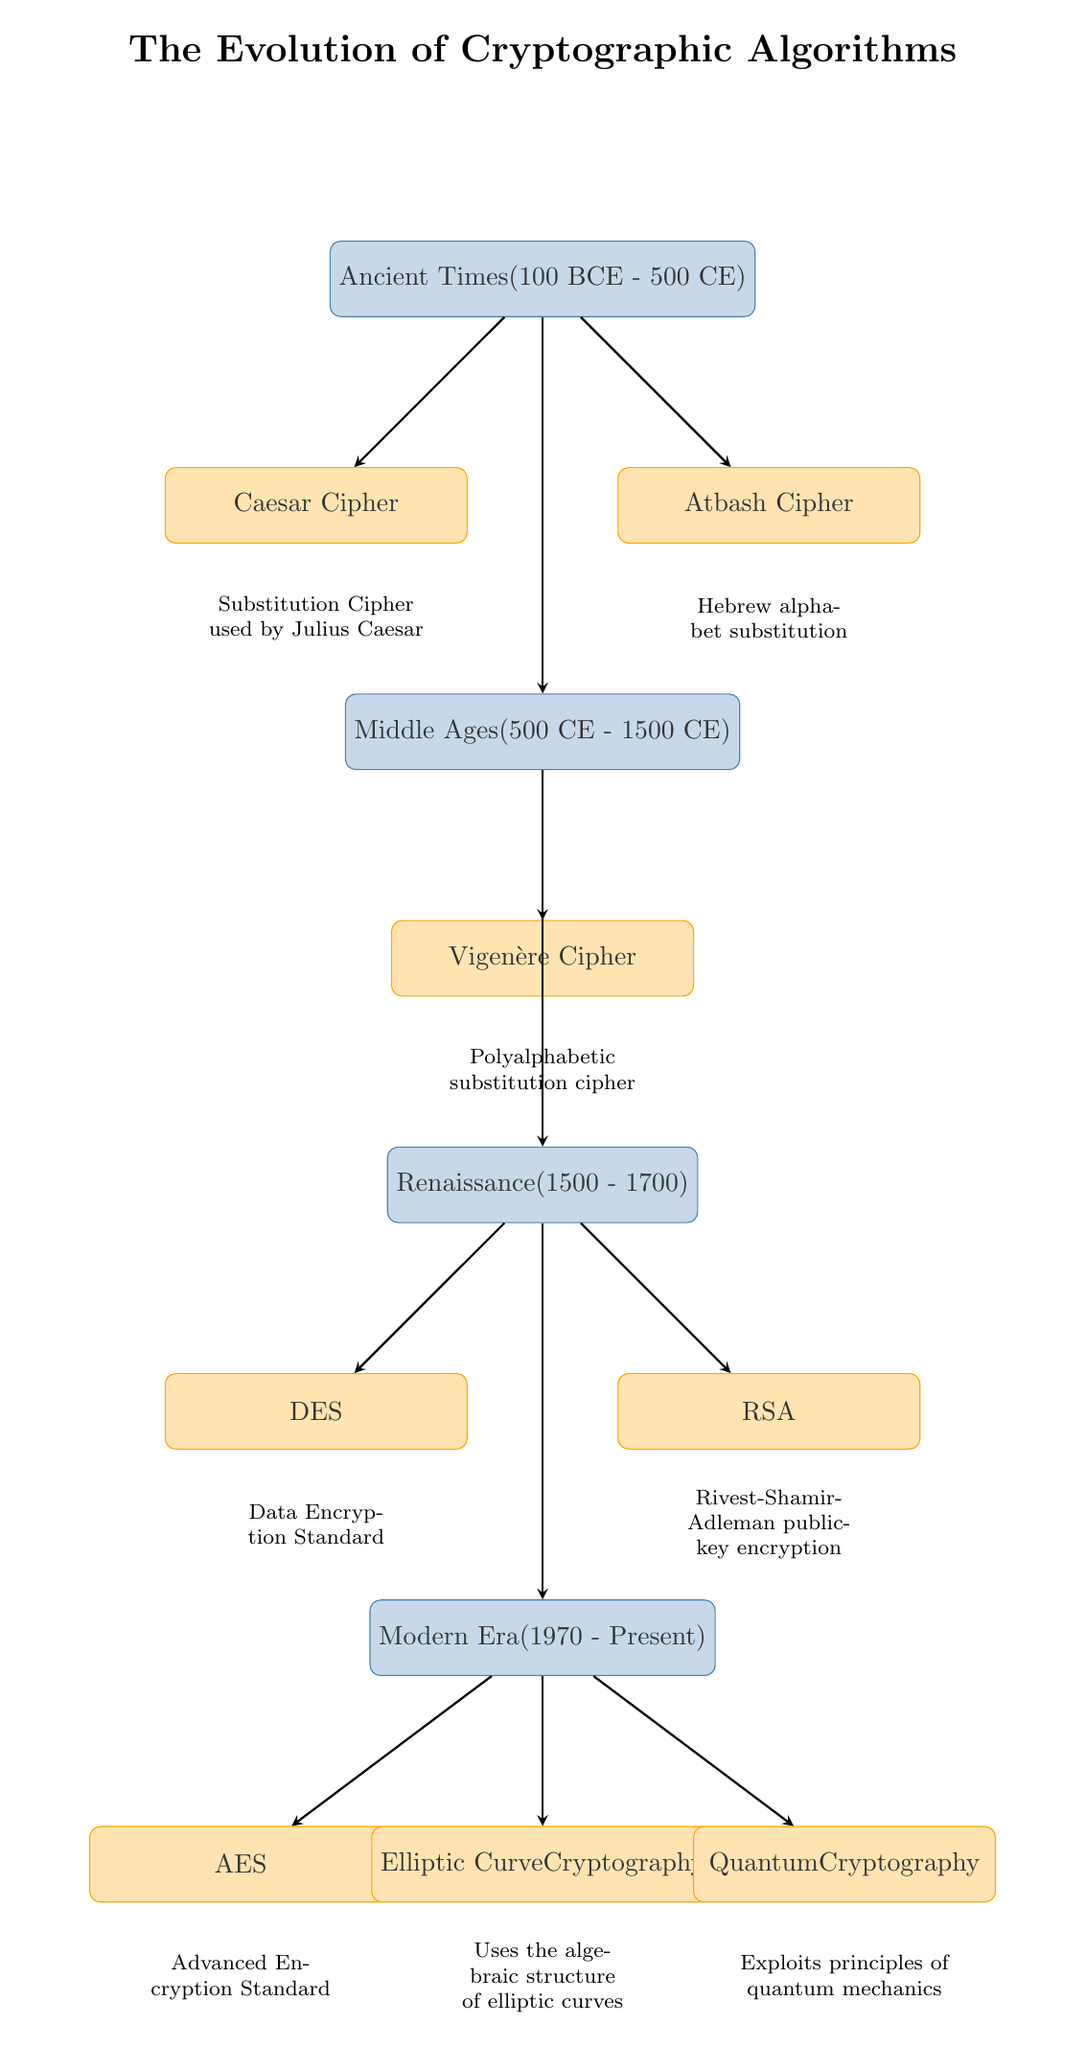What is the first algorithm listed in the diagram? The diagram starts with the node representing the Caesar Cipher, which is the first element under Ancient Times.
Answer: Caesar Cipher How many periods are shown in the diagram? The diagram presents four distinct periods: Ancient Times, Middle Ages, Renaissance, and Modern Era.
Answer: 4 Which cryptographic algorithm is described as a "substitution cipher used by Julius Caesar"? The label directly beneath the node for the Caesar Cipher states, "Substitution Cipher used by Julius Caesar," clearly identifying the algorithm's description.
Answer: Caesar Cipher What period does the Vigenère Cipher belong to? The Vigenère Cipher is listed under the Middle Ages, as indicated by its placement below the corresponding period node.
Answer: Middle Ages What type of encryption does RSA represent? The diagram specifically identifies RSA as "Rivest-Shamir-Adleman public-key encryption," which defines its fundamental characteristic.
Answer: Public-key encryption How do the periods in the diagram progress? The arrows indicate a chronological progression from Ancient Times to Middle Ages, then to Renaissance, and finally to the Modern Era, showing the historical development of cryptographic algorithms.
Answer: Chronological progression What does ECC stand for and which period does it belong to? ECC stands for Elliptic Curve Cryptography, and it is placed in the Modern Era section of the diagram, indicating its contemporary relevance.
Answer: Elliptic Curve Cryptography, Modern Era Which two algorithms are associated with the Renaissance period? The Renaissance period features two algorithms: DES and RSA, as shown by the separate nodes branching from the Renaissance node.
Answer: DES, RSA 